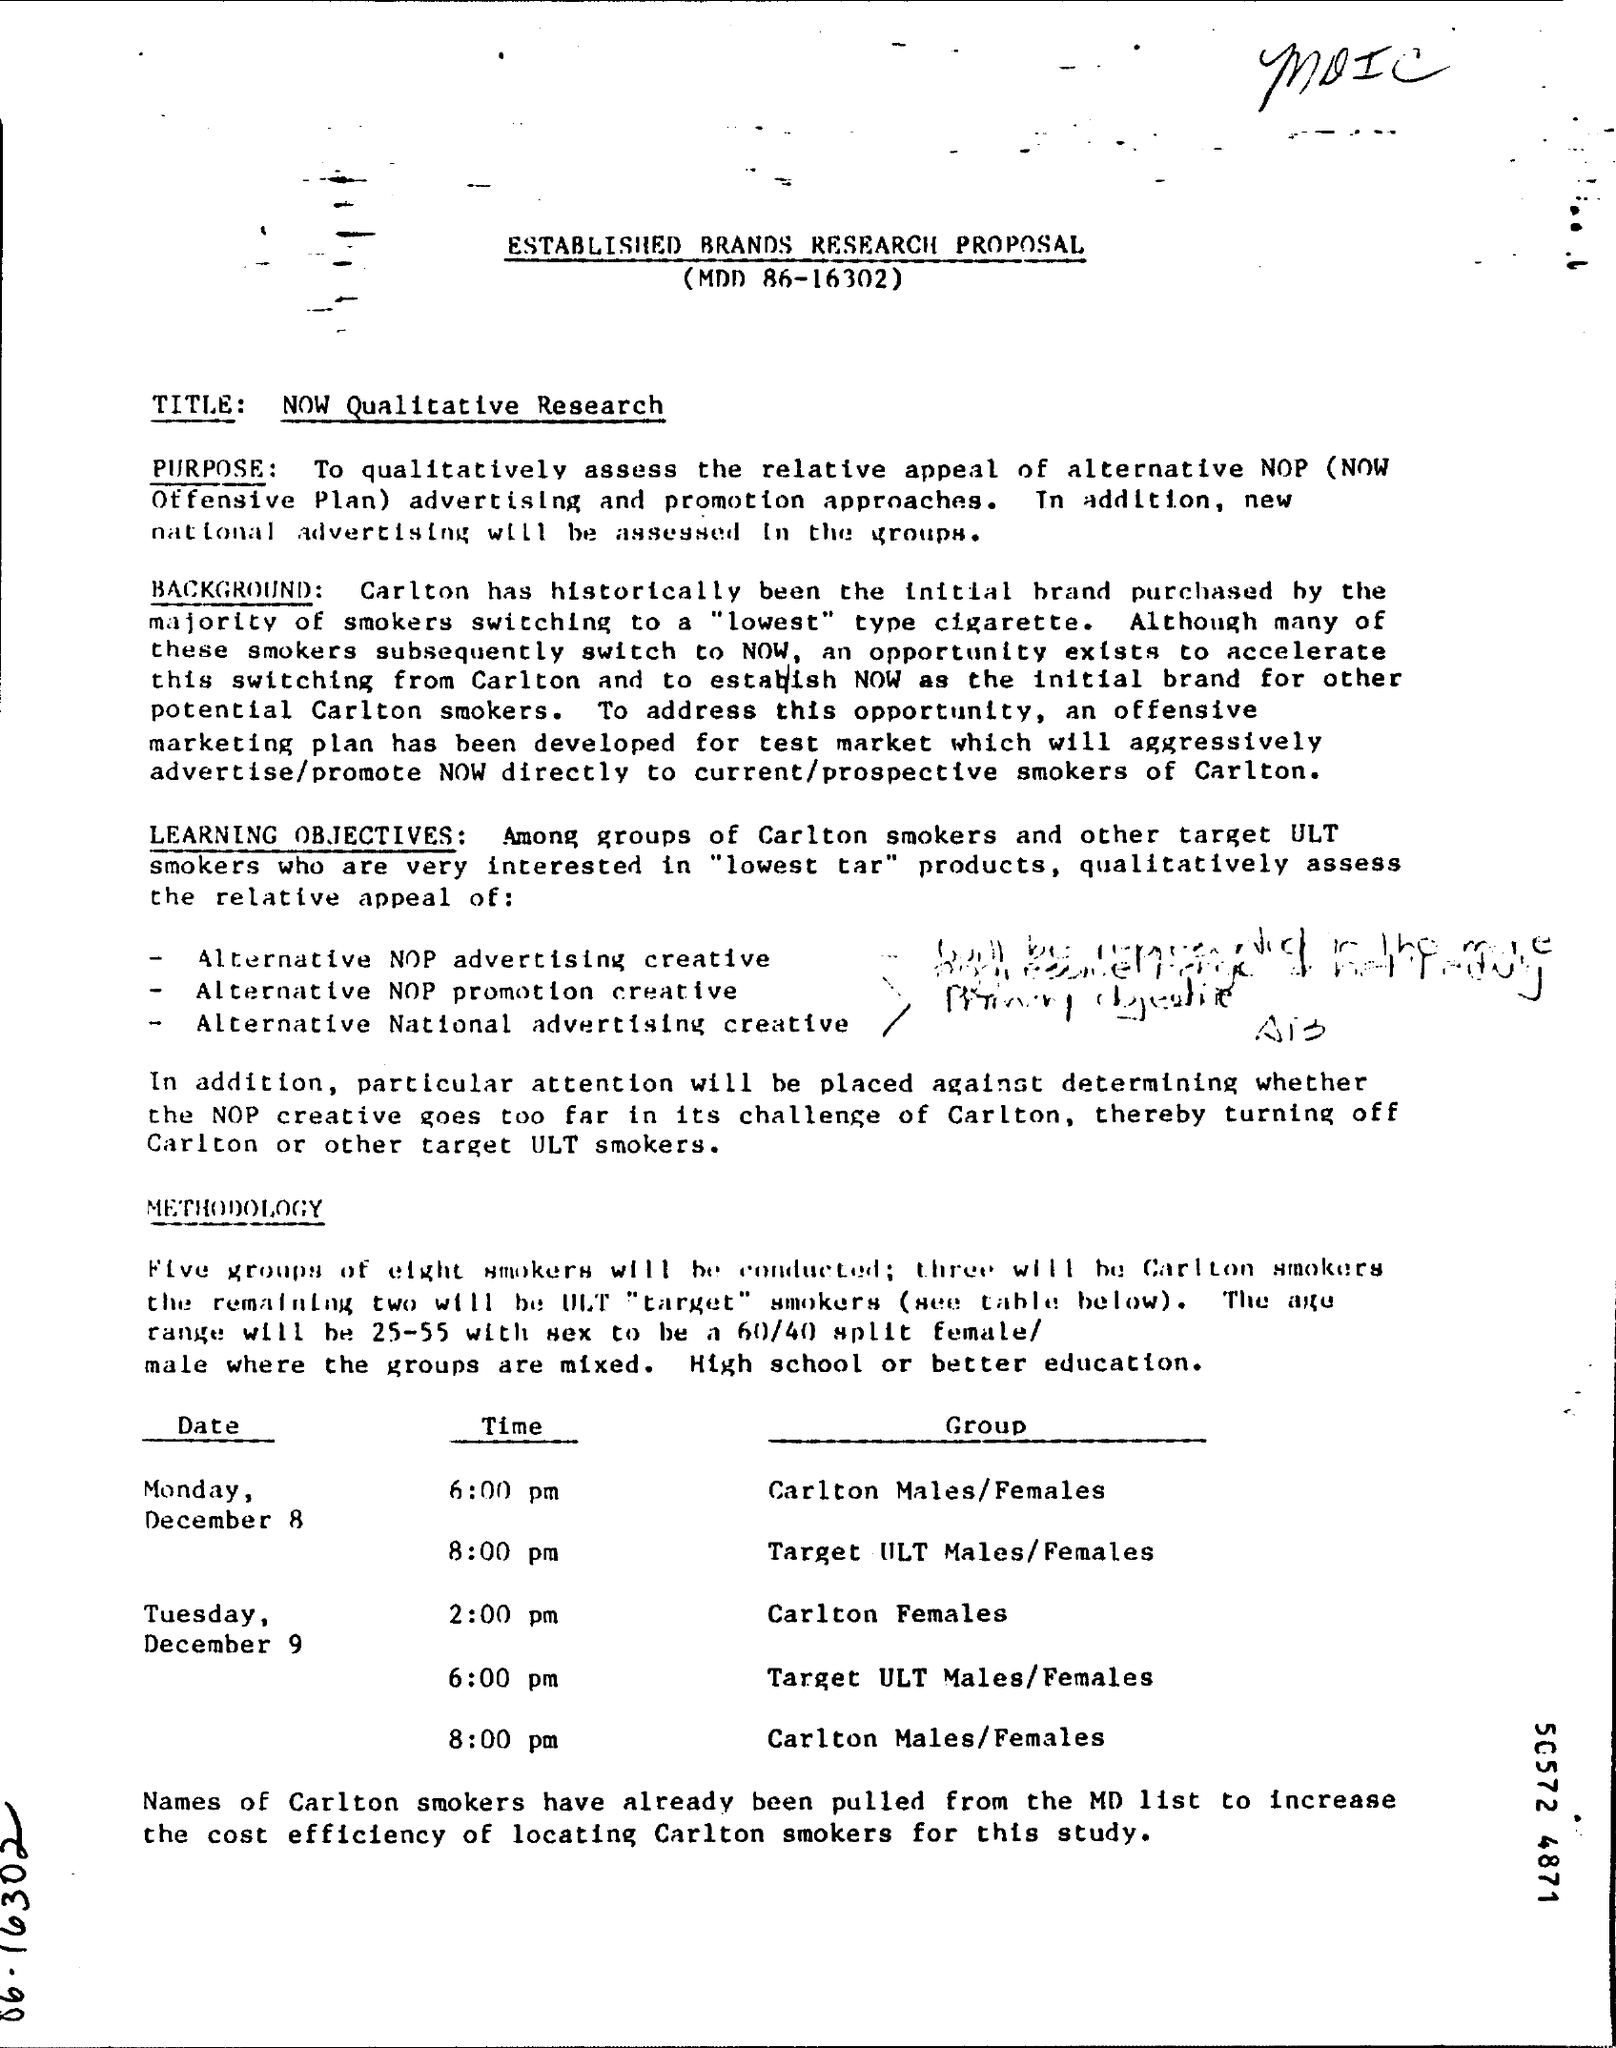List a handful of essential elements in this visual. The acronym 'NOP' stands for 'NOW Offensive Plan', which is a derogatory term that is intended to be offensive and insulting. The most commonly purchased brand among smokers who switch to a low-level cigarette is Carlton. Out of the five groups, three will belong to Carlton. The title of the research is "The Impact of Climate Change on Coastal Ecosystems: A Qualitative Study. 